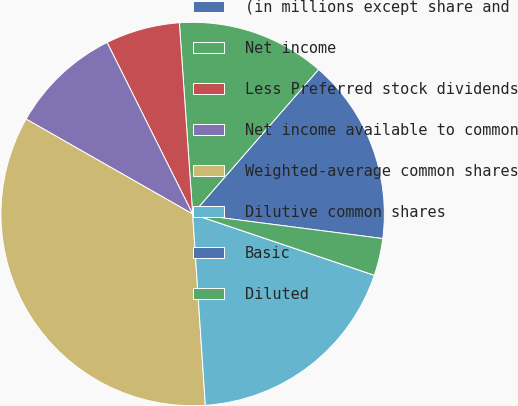<chart> <loc_0><loc_0><loc_500><loc_500><pie_chart><fcel>(in millions except share and<fcel>Net income<fcel>Less Preferred stock dividends<fcel>Net income available to common<fcel>Weighted-average common shares<fcel>Dilutive common shares<fcel>Basic<fcel>Diluted<nl><fcel>15.64%<fcel>12.51%<fcel>6.26%<fcel>9.39%<fcel>34.3%<fcel>18.77%<fcel>0.0%<fcel>3.13%<nl></chart> 